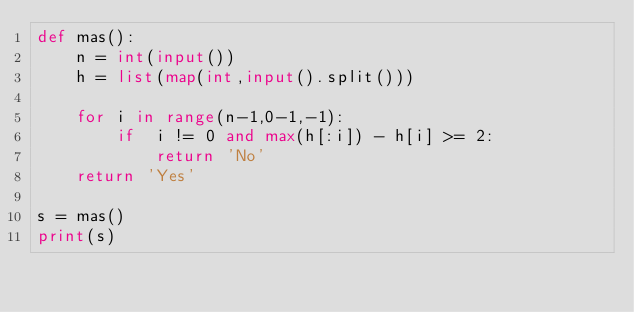Convert code to text. <code><loc_0><loc_0><loc_500><loc_500><_Python_>def mas():
    n = int(input())
    h = list(map(int,input().split()))

    for i in range(n-1,0-1,-1):
        if  i != 0 and max(h[:i]) - h[i] >= 2:
            return 'No'
    return 'Yes'

s = mas()
print(s)</code> 